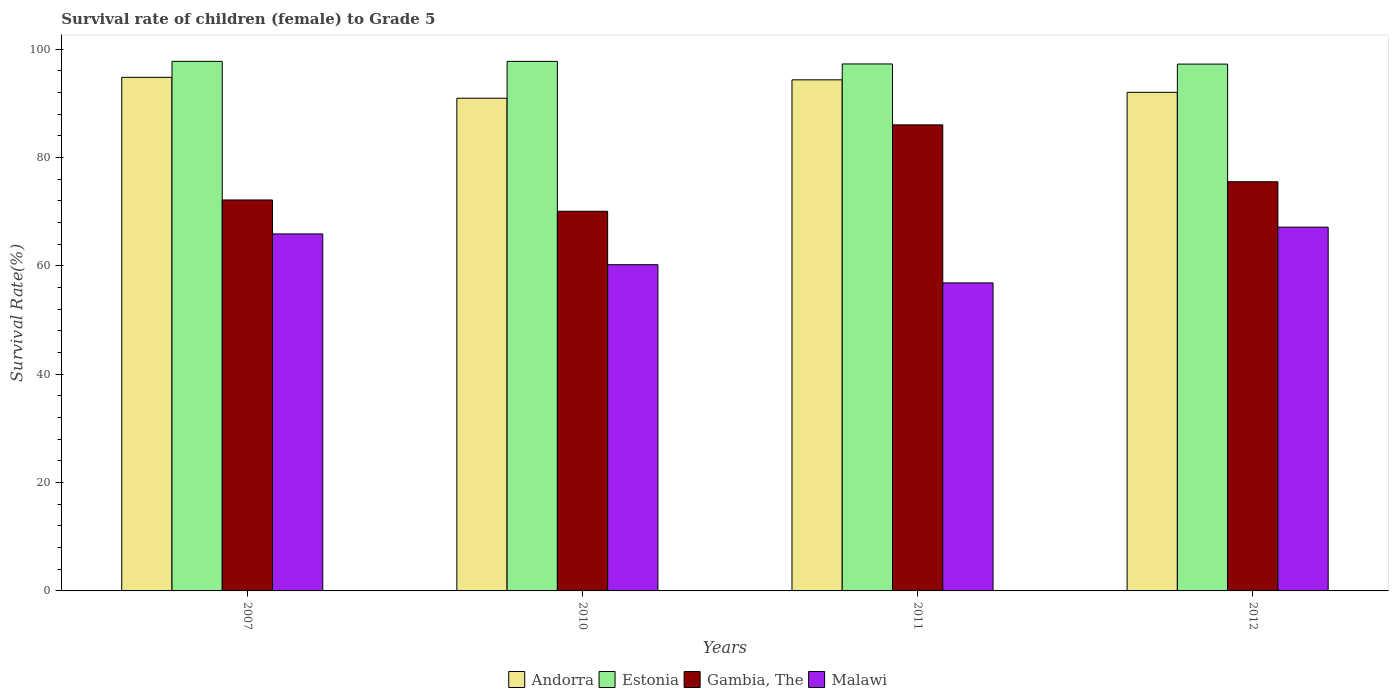How many different coloured bars are there?
Your response must be concise. 4. How many groups of bars are there?
Your response must be concise. 4. Are the number of bars per tick equal to the number of legend labels?
Your response must be concise. Yes. Are the number of bars on each tick of the X-axis equal?
Make the answer very short. Yes. How many bars are there on the 2nd tick from the left?
Your response must be concise. 4. What is the label of the 3rd group of bars from the left?
Your response must be concise. 2011. In how many cases, is the number of bars for a given year not equal to the number of legend labels?
Give a very brief answer. 0. What is the survival rate of female children to grade 5 in Andorra in 2010?
Ensure brevity in your answer.  90.92. Across all years, what is the maximum survival rate of female children to grade 5 in Malawi?
Offer a terse response. 67.13. Across all years, what is the minimum survival rate of female children to grade 5 in Gambia, The?
Provide a short and direct response. 70.06. In which year was the survival rate of female children to grade 5 in Andorra maximum?
Keep it short and to the point. 2007. In which year was the survival rate of female children to grade 5 in Andorra minimum?
Give a very brief answer. 2010. What is the total survival rate of female children to grade 5 in Gambia, The in the graph?
Offer a very short reply. 303.71. What is the difference between the survival rate of female children to grade 5 in Estonia in 2007 and that in 2012?
Offer a very short reply. 0.51. What is the difference between the survival rate of female children to grade 5 in Estonia in 2007 and the survival rate of female children to grade 5 in Andorra in 2010?
Offer a very short reply. 6.8. What is the average survival rate of female children to grade 5 in Estonia per year?
Keep it short and to the point. 97.48. In the year 2012, what is the difference between the survival rate of female children to grade 5 in Gambia, The and survival rate of female children to grade 5 in Estonia?
Your answer should be compact. -21.71. What is the ratio of the survival rate of female children to grade 5 in Malawi in 2007 to that in 2010?
Keep it short and to the point. 1.09. Is the difference between the survival rate of female children to grade 5 in Gambia, The in 2010 and 2012 greater than the difference between the survival rate of female children to grade 5 in Estonia in 2010 and 2012?
Give a very brief answer. No. What is the difference between the highest and the second highest survival rate of female children to grade 5 in Malawi?
Ensure brevity in your answer.  1.25. What is the difference between the highest and the lowest survival rate of female children to grade 5 in Malawi?
Your answer should be compact. 10.29. Is it the case that in every year, the sum of the survival rate of female children to grade 5 in Estonia and survival rate of female children to grade 5 in Malawi is greater than the sum of survival rate of female children to grade 5 in Andorra and survival rate of female children to grade 5 in Gambia, The?
Offer a terse response. No. What does the 2nd bar from the left in 2011 represents?
Offer a very short reply. Estonia. What does the 4th bar from the right in 2007 represents?
Keep it short and to the point. Andorra. Are all the bars in the graph horizontal?
Ensure brevity in your answer.  No. What is the difference between two consecutive major ticks on the Y-axis?
Offer a terse response. 20. Are the values on the major ticks of Y-axis written in scientific E-notation?
Offer a terse response. No. Does the graph contain any zero values?
Keep it short and to the point. No. Does the graph contain grids?
Provide a short and direct response. No. How many legend labels are there?
Provide a succinct answer. 4. How are the legend labels stacked?
Your answer should be very brief. Horizontal. What is the title of the graph?
Provide a short and direct response. Survival rate of children (female) to Grade 5. What is the label or title of the Y-axis?
Make the answer very short. Survival Rate(%). What is the Survival Rate(%) of Andorra in 2007?
Offer a very short reply. 94.78. What is the Survival Rate(%) in Estonia in 2007?
Your answer should be very brief. 97.72. What is the Survival Rate(%) in Gambia, The in 2007?
Ensure brevity in your answer.  72.14. What is the Survival Rate(%) of Malawi in 2007?
Offer a very short reply. 65.88. What is the Survival Rate(%) of Andorra in 2010?
Provide a short and direct response. 90.92. What is the Survival Rate(%) in Estonia in 2010?
Ensure brevity in your answer.  97.72. What is the Survival Rate(%) in Gambia, The in 2010?
Offer a very short reply. 70.06. What is the Survival Rate(%) of Malawi in 2010?
Your response must be concise. 60.2. What is the Survival Rate(%) of Andorra in 2011?
Ensure brevity in your answer.  94.31. What is the Survival Rate(%) of Estonia in 2011?
Provide a short and direct response. 97.24. What is the Survival Rate(%) in Gambia, The in 2011?
Provide a short and direct response. 86. What is the Survival Rate(%) of Malawi in 2011?
Offer a very short reply. 56.84. What is the Survival Rate(%) in Andorra in 2012?
Offer a terse response. 92.01. What is the Survival Rate(%) in Estonia in 2012?
Provide a succinct answer. 97.22. What is the Survival Rate(%) of Gambia, The in 2012?
Keep it short and to the point. 75.5. What is the Survival Rate(%) in Malawi in 2012?
Your answer should be compact. 67.13. Across all years, what is the maximum Survival Rate(%) in Andorra?
Your response must be concise. 94.78. Across all years, what is the maximum Survival Rate(%) of Estonia?
Provide a short and direct response. 97.72. Across all years, what is the maximum Survival Rate(%) in Gambia, The?
Your answer should be very brief. 86. Across all years, what is the maximum Survival Rate(%) of Malawi?
Ensure brevity in your answer.  67.13. Across all years, what is the minimum Survival Rate(%) of Andorra?
Provide a short and direct response. 90.92. Across all years, what is the minimum Survival Rate(%) of Estonia?
Your response must be concise. 97.22. Across all years, what is the minimum Survival Rate(%) of Gambia, The?
Provide a succinct answer. 70.06. Across all years, what is the minimum Survival Rate(%) in Malawi?
Make the answer very short. 56.84. What is the total Survival Rate(%) in Andorra in the graph?
Keep it short and to the point. 372.02. What is the total Survival Rate(%) in Estonia in the graph?
Your answer should be very brief. 389.9. What is the total Survival Rate(%) of Gambia, The in the graph?
Give a very brief answer. 303.71. What is the total Survival Rate(%) in Malawi in the graph?
Offer a very short reply. 250.05. What is the difference between the Survival Rate(%) of Andorra in 2007 and that in 2010?
Make the answer very short. 3.85. What is the difference between the Survival Rate(%) in Estonia in 2007 and that in 2010?
Give a very brief answer. 0. What is the difference between the Survival Rate(%) of Gambia, The in 2007 and that in 2010?
Keep it short and to the point. 2.08. What is the difference between the Survival Rate(%) of Malawi in 2007 and that in 2010?
Your answer should be very brief. 5.68. What is the difference between the Survival Rate(%) in Andorra in 2007 and that in 2011?
Offer a terse response. 0.46. What is the difference between the Survival Rate(%) of Estonia in 2007 and that in 2011?
Provide a short and direct response. 0.48. What is the difference between the Survival Rate(%) in Gambia, The in 2007 and that in 2011?
Provide a short and direct response. -13.86. What is the difference between the Survival Rate(%) in Malawi in 2007 and that in 2011?
Your answer should be very brief. 9.04. What is the difference between the Survival Rate(%) of Andorra in 2007 and that in 2012?
Make the answer very short. 2.77. What is the difference between the Survival Rate(%) in Estonia in 2007 and that in 2012?
Provide a succinct answer. 0.51. What is the difference between the Survival Rate(%) in Gambia, The in 2007 and that in 2012?
Your response must be concise. -3.36. What is the difference between the Survival Rate(%) in Malawi in 2007 and that in 2012?
Keep it short and to the point. -1.25. What is the difference between the Survival Rate(%) of Andorra in 2010 and that in 2011?
Your answer should be very brief. -3.39. What is the difference between the Survival Rate(%) in Estonia in 2010 and that in 2011?
Make the answer very short. 0.48. What is the difference between the Survival Rate(%) of Gambia, The in 2010 and that in 2011?
Your answer should be very brief. -15.94. What is the difference between the Survival Rate(%) in Malawi in 2010 and that in 2011?
Your response must be concise. 3.36. What is the difference between the Survival Rate(%) in Andorra in 2010 and that in 2012?
Offer a very short reply. -1.09. What is the difference between the Survival Rate(%) of Estonia in 2010 and that in 2012?
Provide a short and direct response. 0.5. What is the difference between the Survival Rate(%) of Gambia, The in 2010 and that in 2012?
Offer a very short reply. -5.45. What is the difference between the Survival Rate(%) in Malawi in 2010 and that in 2012?
Your answer should be compact. -6.93. What is the difference between the Survival Rate(%) of Andorra in 2011 and that in 2012?
Your response must be concise. 2.3. What is the difference between the Survival Rate(%) in Estonia in 2011 and that in 2012?
Give a very brief answer. 0.03. What is the difference between the Survival Rate(%) in Gambia, The in 2011 and that in 2012?
Offer a very short reply. 10.5. What is the difference between the Survival Rate(%) of Malawi in 2011 and that in 2012?
Your answer should be very brief. -10.29. What is the difference between the Survival Rate(%) of Andorra in 2007 and the Survival Rate(%) of Estonia in 2010?
Your response must be concise. -2.94. What is the difference between the Survival Rate(%) in Andorra in 2007 and the Survival Rate(%) in Gambia, The in 2010?
Provide a succinct answer. 24.72. What is the difference between the Survival Rate(%) of Andorra in 2007 and the Survival Rate(%) of Malawi in 2010?
Provide a short and direct response. 34.58. What is the difference between the Survival Rate(%) of Estonia in 2007 and the Survival Rate(%) of Gambia, The in 2010?
Your answer should be very brief. 27.67. What is the difference between the Survival Rate(%) of Estonia in 2007 and the Survival Rate(%) of Malawi in 2010?
Give a very brief answer. 37.53. What is the difference between the Survival Rate(%) in Gambia, The in 2007 and the Survival Rate(%) in Malawi in 2010?
Keep it short and to the point. 11.95. What is the difference between the Survival Rate(%) in Andorra in 2007 and the Survival Rate(%) in Estonia in 2011?
Make the answer very short. -2.47. What is the difference between the Survival Rate(%) of Andorra in 2007 and the Survival Rate(%) of Gambia, The in 2011?
Keep it short and to the point. 8.77. What is the difference between the Survival Rate(%) in Andorra in 2007 and the Survival Rate(%) in Malawi in 2011?
Give a very brief answer. 37.93. What is the difference between the Survival Rate(%) of Estonia in 2007 and the Survival Rate(%) of Gambia, The in 2011?
Offer a terse response. 11.72. What is the difference between the Survival Rate(%) in Estonia in 2007 and the Survival Rate(%) in Malawi in 2011?
Your answer should be very brief. 40.88. What is the difference between the Survival Rate(%) of Gambia, The in 2007 and the Survival Rate(%) of Malawi in 2011?
Keep it short and to the point. 15.3. What is the difference between the Survival Rate(%) in Andorra in 2007 and the Survival Rate(%) in Estonia in 2012?
Your answer should be very brief. -2.44. What is the difference between the Survival Rate(%) of Andorra in 2007 and the Survival Rate(%) of Gambia, The in 2012?
Offer a terse response. 19.27. What is the difference between the Survival Rate(%) in Andorra in 2007 and the Survival Rate(%) in Malawi in 2012?
Make the answer very short. 27.64. What is the difference between the Survival Rate(%) in Estonia in 2007 and the Survival Rate(%) in Gambia, The in 2012?
Provide a short and direct response. 22.22. What is the difference between the Survival Rate(%) of Estonia in 2007 and the Survival Rate(%) of Malawi in 2012?
Give a very brief answer. 30.59. What is the difference between the Survival Rate(%) in Gambia, The in 2007 and the Survival Rate(%) in Malawi in 2012?
Your answer should be very brief. 5.01. What is the difference between the Survival Rate(%) of Andorra in 2010 and the Survival Rate(%) of Estonia in 2011?
Your response must be concise. -6.32. What is the difference between the Survival Rate(%) of Andorra in 2010 and the Survival Rate(%) of Gambia, The in 2011?
Keep it short and to the point. 4.92. What is the difference between the Survival Rate(%) of Andorra in 2010 and the Survival Rate(%) of Malawi in 2011?
Offer a very short reply. 34.08. What is the difference between the Survival Rate(%) in Estonia in 2010 and the Survival Rate(%) in Gambia, The in 2011?
Your answer should be compact. 11.72. What is the difference between the Survival Rate(%) in Estonia in 2010 and the Survival Rate(%) in Malawi in 2011?
Your answer should be compact. 40.88. What is the difference between the Survival Rate(%) of Gambia, The in 2010 and the Survival Rate(%) of Malawi in 2011?
Your response must be concise. 13.22. What is the difference between the Survival Rate(%) of Andorra in 2010 and the Survival Rate(%) of Estonia in 2012?
Keep it short and to the point. -6.29. What is the difference between the Survival Rate(%) in Andorra in 2010 and the Survival Rate(%) in Gambia, The in 2012?
Offer a terse response. 15.42. What is the difference between the Survival Rate(%) of Andorra in 2010 and the Survival Rate(%) of Malawi in 2012?
Offer a terse response. 23.79. What is the difference between the Survival Rate(%) of Estonia in 2010 and the Survival Rate(%) of Gambia, The in 2012?
Ensure brevity in your answer.  22.22. What is the difference between the Survival Rate(%) in Estonia in 2010 and the Survival Rate(%) in Malawi in 2012?
Your answer should be very brief. 30.59. What is the difference between the Survival Rate(%) of Gambia, The in 2010 and the Survival Rate(%) of Malawi in 2012?
Give a very brief answer. 2.93. What is the difference between the Survival Rate(%) in Andorra in 2011 and the Survival Rate(%) in Estonia in 2012?
Provide a short and direct response. -2.9. What is the difference between the Survival Rate(%) in Andorra in 2011 and the Survival Rate(%) in Gambia, The in 2012?
Provide a succinct answer. 18.81. What is the difference between the Survival Rate(%) of Andorra in 2011 and the Survival Rate(%) of Malawi in 2012?
Offer a terse response. 27.18. What is the difference between the Survival Rate(%) of Estonia in 2011 and the Survival Rate(%) of Gambia, The in 2012?
Ensure brevity in your answer.  21.74. What is the difference between the Survival Rate(%) in Estonia in 2011 and the Survival Rate(%) in Malawi in 2012?
Provide a short and direct response. 30.11. What is the difference between the Survival Rate(%) of Gambia, The in 2011 and the Survival Rate(%) of Malawi in 2012?
Your answer should be very brief. 18.87. What is the average Survival Rate(%) of Andorra per year?
Keep it short and to the point. 93.01. What is the average Survival Rate(%) in Estonia per year?
Your answer should be compact. 97.48. What is the average Survival Rate(%) in Gambia, The per year?
Give a very brief answer. 75.93. What is the average Survival Rate(%) of Malawi per year?
Offer a terse response. 62.51. In the year 2007, what is the difference between the Survival Rate(%) in Andorra and Survival Rate(%) in Estonia?
Your response must be concise. -2.95. In the year 2007, what is the difference between the Survival Rate(%) in Andorra and Survival Rate(%) in Gambia, The?
Your response must be concise. 22.63. In the year 2007, what is the difference between the Survival Rate(%) of Andorra and Survival Rate(%) of Malawi?
Ensure brevity in your answer.  28.9. In the year 2007, what is the difference between the Survival Rate(%) of Estonia and Survival Rate(%) of Gambia, The?
Ensure brevity in your answer.  25.58. In the year 2007, what is the difference between the Survival Rate(%) in Estonia and Survival Rate(%) in Malawi?
Your answer should be very brief. 31.84. In the year 2007, what is the difference between the Survival Rate(%) in Gambia, The and Survival Rate(%) in Malawi?
Provide a short and direct response. 6.26. In the year 2010, what is the difference between the Survival Rate(%) in Andorra and Survival Rate(%) in Estonia?
Make the answer very short. -6.8. In the year 2010, what is the difference between the Survival Rate(%) in Andorra and Survival Rate(%) in Gambia, The?
Offer a very short reply. 20.86. In the year 2010, what is the difference between the Survival Rate(%) in Andorra and Survival Rate(%) in Malawi?
Keep it short and to the point. 30.73. In the year 2010, what is the difference between the Survival Rate(%) in Estonia and Survival Rate(%) in Gambia, The?
Provide a succinct answer. 27.66. In the year 2010, what is the difference between the Survival Rate(%) in Estonia and Survival Rate(%) in Malawi?
Keep it short and to the point. 37.52. In the year 2010, what is the difference between the Survival Rate(%) of Gambia, The and Survival Rate(%) of Malawi?
Your answer should be compact. 9.86. In the year 2011, what is the difference between the Survival Rate(%) in Andorra and Survival Rate(%) in Estonia?
Provide a short and direct response. -2.93. In the year 2011, what is the difference between the Survival Rate(%) of Andorra and Survival Rate(%) of Gambia, The?
Offer a terse response. 8.31. In the year 2011, what is the difference between the Survival Rate(%) in Andorra and Survival Rate(%) in Malawi?
Provide a short and direct response. 37.47. In the year 2011, what is the difference between the Survival Rate(%) of Estonia and Survival Rate(%) of Gambia, The?
Offer a terse response. 11.24. In the year 2011, what is the difference between the Survival Rate(%) of Estonia and Survival Rate(%) of Malawi?
Provide a succinct answer. 40.4. In the year 2011, what is the difference between the Survival Rate(%) of Gambia, The and Survival Rate(%) of Malawi?
Offer a very short reply. 29.16. In the year 2012, what is the difference between the Survival Rate(%) of Andorra and Survival Rate(%) of Estonia?
Offer a terse response. -5.21. In the year 2012, what is the difference between the Survival Rate(%) of Andorra and Survival Rate(%) of Gambia, The?
Provide a succinct answer. 16.51. In the year 2012, what is the difference between the Survival Rate(%) of Andorra and Survival Rate(%) of Malawi?
Provide a short and direct response. 24.88. In the year 2012, what is the difference between the Survival Rate(%) in Estonia and Survival Rate(%) in Gambia, The?
Provide a short and direct response. 21.71. In the year 2012, what is the difference between the Survival Rate(%) of Estonia and Survival Rate(%) of Malawi?
Your answer should be compact. 30.08. In the year 2012, what is the difference between the Survival Rate(%) of Gambia, The and Survival Rate(%) of Malawi?
Keep it short and to the point. 8.37. What is the ratio of the Survival Rate(%) of Andorra in 2007 to that in 2010?
Make the answer very short. 1.04. What is the ratio of the Survival Rate(%) in Estonia in 2007 to that in 2010?
Provide a succinct answer. 1. What is the ratio of the Survival Rate(%) of Gambia, The in 2007 to that in 2010?
Your answer should be very brief. 1.03. What is the ratio of the Survival Rate(%) in Malawi in 2007 to that in 2010?
Ensure brevity in your answer.  1.09. What is the ratio of the Survival Rate(%) in Andorra in 2007 to that in 2011?
Make the answer very short. 1. What is the ratio of the Survival Rate(%) of Estonia in 2007 to that in 2011?
Your answer should be very brief. 1. What is the ratio of the Survival Rate(%) of Gambia, The in 2007 to that in 2011?
Provide a succinct answer. 0.84. What is the ratio of the Survival Rate(%) of Malawi in 2007 to that in 2011?
Provide a succinct answer. 1.16. What is the ratio of the Survival Rate(%) of Andorra in 2007 to that in 2012?
Make the answer very short. 1.03. What is the ratio of the Survival Rate(%) of Estonia in 2007 to that in 2012?
Offer a terse response. 1.01. What is the ratio of the Survival Rate(%) of Gambia, The in 2007 to that in 2012?
Provide a succinct answer. 0.96. What is the ratio of the Survival Rate(%) in Malawi in 2007 to that in 2012?
Offer a very short reply. 0.98. What is the ratio of the Survival Rate(%) in Andorra in 2010 to that in 2011?
Provide a succinct answer. 0.96. What is the ratio of the Survival Rate(%) in Gambia, The in 2010 to that in 2011?
Keep it short and to the point. 0.81. What is the ratio of the Survival Rate(%) in Malawi in 2010 to that in 2011?
Offer a terse response. 1.06. What is the ratio of the Survival Rate(%) of Gambia, The in 2010 to that in 2012?
Provide a succinct answer. 0.93. What is the ratio of the Survival Rate(%) of Malawi in 2010 to that in 2012?
Ensure brevity in your answer.  0.9. What is the ratio of the Survival Rate(%) of Gambia, The in 2011 to that in 2012?
Ensure brevity in your answer.  1.14. What is the ratio of the Survival Rate(%) of Malawi in 2011 to that in 2012?
Your answer should be very brief. 0.85. What is the difference between the highest and the second highest Survival Rate(%) in Andorra?
Ensure brevity in your answer.  0.46. What is the difference between the highest and the second highest Survival Rate(%) of Estonia?
Your answer should be compact. 0. What is the difference between the highest and the second highest Survival Rate(%) in Gambia, The?
Your answer should be very brief. 10.5. What is the difference between the highest and the second highest Survival Rate(%) in Malawi?
Ensure brevity in your answer.  1.25. What is the difference between the highest and the lowest Survival Rate(%) in Andorra?
Your answer should be compact. 3.85. What is the difference between the highest and the lowest Survival Rate(%) in Estonia?
Your response must be concise. 0.51. What is the difference between the highest and the lowest Survival Rate(%) in Gambia, The?
Your answer should be very brief. 15.94. What is the difference between the highest and the lowest Survival Rate(%) in Malawi?
Make the answer very short. 10.29. 